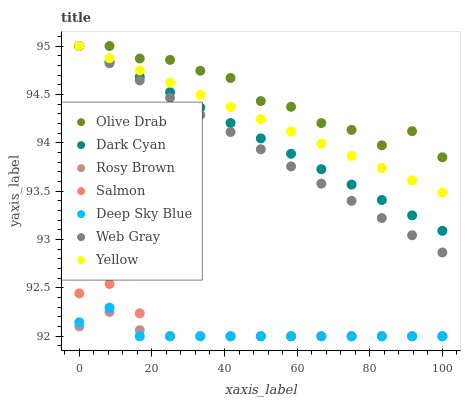Does Rosy Brown have the minimum area under the curve?
Answer yes or no. Yes. Does Olive Drab have the maximum area under the curve?
Answer yes or no. Yes. Does Salmon have the minimum area under the curve?
Answer yes or no. No. Does Salmon have the maximum area under the curve?
Answer yes or no. No. Is Yellow the smoothest?
Answer yes or no. Yes. Is Olive Drab the roughest?
Answer yes or no. Yes. Is Rosy Brown the smoothest?
Answer yes or no. No. Is Rosy Brown the roughest?
Answer yes or no. No. Does Rosy Brown have the lowest value?
Answer yes or no. Yes. Does Yellow have the lowest value?
Answer yes or no. No. Does Olive Drab have the highest value?
Answer yes or no. Yes. Does Salmon have the highest value?
Answer yes or no. No. Is Rosy Brown less than Dark Cyan?
Answer yes or no. Yes. Is Yellow greater than Rosy Brown?
Answer yes or no. Yes. Does Deep Sky Blue intersect Salmon?
Answer yes or no. Yes. Is Deep Sky Blue less than Salmon?
Answer yes or no. No. Is Deep Sky Blue greater than Salmon?
Answer yes or no. No. Does Rosy Brown intersect Dark Cyan?
Answer yes or no. No. 